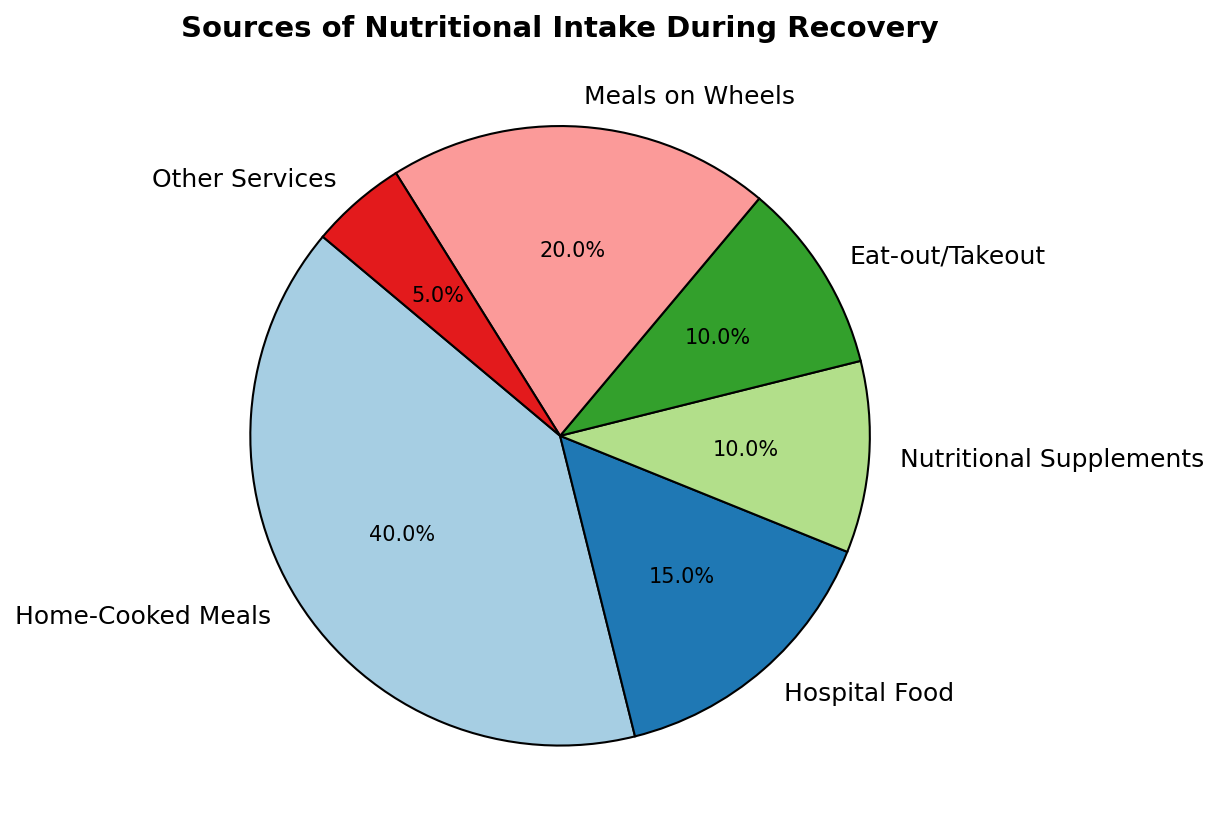What percentage of nutritional intake comes from home-cooked meals? Home-cooked meals account for 40% of the nutritional intake during recovery. This information is directly available from the figure where 'Home-Cooked Meals' segment is labeled with 40%.
Answer: 40% How does the percentage of hospital food compare to meals on wheels? Hospital food constitutes 15% of the nutritional intake, while Meals on Wheels account for 20%. Comparing these two, we find that Meals on Wheels provides a greater percentage (20%) compared to hospital food (15%).
Answer: Meals on Wheels is 5% higher What are the two smallest sources of nutritional intake? The two smallest sources of nutritional intake are 'Nutritional Supplements' and 'Other Services'. The figure shows that these segments are labeled with 10% and 5% respectively, which are the smallest percentages on the chart.
Answer: Nutritional Supplements and Other Services What is the total percentage of nutritional intake covered by home-cooked meals and eat-out/takeout? Home-cooked meals account for 40% and eat-out/takeout accounts for 10%. Summing these two values, we get 40% + 10% = 50%.
Answer: 50% How does the percentage of nutritional supplements compare to other services? Nutritional Supplements account for 10%, while Other Services account for 5%. The figure clearly shows that Nutritional Supplements provide a higher percentage (10%) compared to Other Services (5%).
Answer: Nutritional Supplements is 5% higher What is the difference between the highest and lowest sources of nutritional intake? The highest source is Home-Cooked Meals at 40%, and the lowest is Other Services at 5%. The difference is calculated by subtracting the smallest from the largest: 40% - 5% = 35%.
Answer: 35% Which source of nutritional intake has the second highest contribution? The second highest contribution comes from Meals on Wheels, which accounts for 20% of the nutritional intake. The highest is Home-Cooked Meals (40%), and the second highest is indicated as 20% in the figure.
Answer: Meals on Wheels What percentage of nutritional intake is provided by non-home sources (excluding home-cooked meals)? To find this, sum up the percentages of all other sources except home-cooked meals: 15% (Hospital Food) + 10% (Nutritional Supplements) + 10% (Eat-out/Takeout) + 20% (Meals on Wheels) + 5% (Other Services) = 60%.
Answer: 60% Which two sources contribute equally to the nutritional intake? Nutritional Supplements and Eat-out/Takeout both contribute 10% each. The figure shows that these two segments each have labels indicating 10%.
Answer: Nutritional Supplements and Eat-out/Takeout 